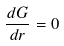Convert formula to latex. <formula><loc_0><loc_0><loc_500><loc_500>\frac { d G } { d r } = 0</formula> 